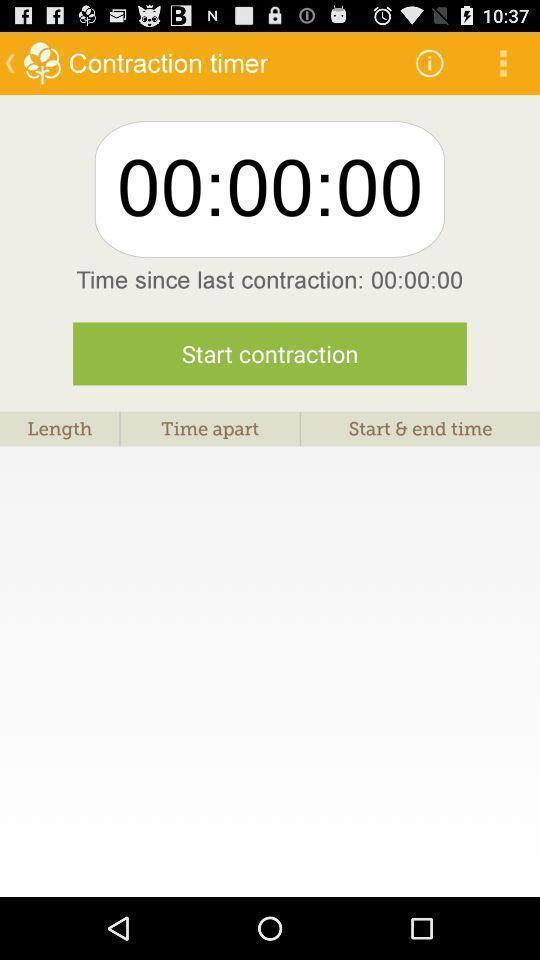Tell me about the visual elements in this screen capture. Screen showing contraction timer. 